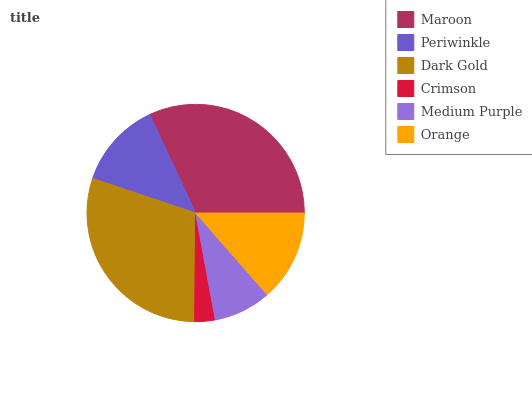Is Crimson the minimum?
Answer yes or no. Yes. Is Maroon the maximum?
Answer yes or no. Yes. Is Periwinkle the minimum?
Answer yes or no. No. Is Periwinkle the maximum?
Answer yes or no. No. Is Maroon greater than Periwinkle?
Answer yes or no. Yes. Is Periwinkle less than Maroon?
Answer yes or no. Yes. Is Periwinkle greater than Maroon?
Answer yes or no. No. Is Maroon less than Periwinkle?
Answer yes or no. No. Is Orange the high median?
Answer yes or no. Yes. Is Periwinkle the low median?
Answer yes or no. Yes. Is Periwinkle the high median?
Answer yes or no. No. Is Orange the low median?
Answer yes or no. No. 